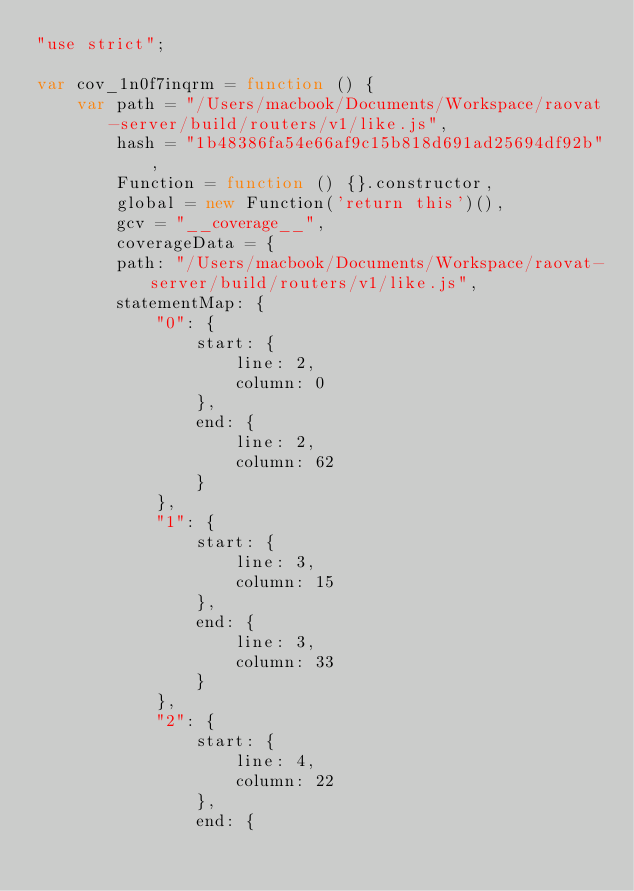Convert code to text. <code><loc_0><loc_0><loc_500><loc_500><_JavaScript_>"use strict";

var cov_1n0f7inqrm = function () {
    var path = "/Users/macbook/Documents/Workspace/raovat-server/build/routers/v1/like.js",
        hash = "1b48386fa54e66af9c15b818d691ad25694df92b",
        Function = function () {}.constructor,
        global = new Function('return this')(),
        gcv = "__coverage__",
        coverageData = {
        path: "/Users/macbook/Documents/Workspace/raovat-server/build/routers/v1/like.js",
        statementMap: {
            "0": {
                start: {
                    line: 2,
                    column: 0
                },
                end: {
                    line: 2,
                    column: 62
                }
            },
            "1": {
                start: {
                    line: 3,
                    column: 15
                },
                end: {
                    line: 3,
                    column: 33
                }
            },
            "2": {
                start: {
                    line: 4,
                    column: 22
                },
                end: {</code> 